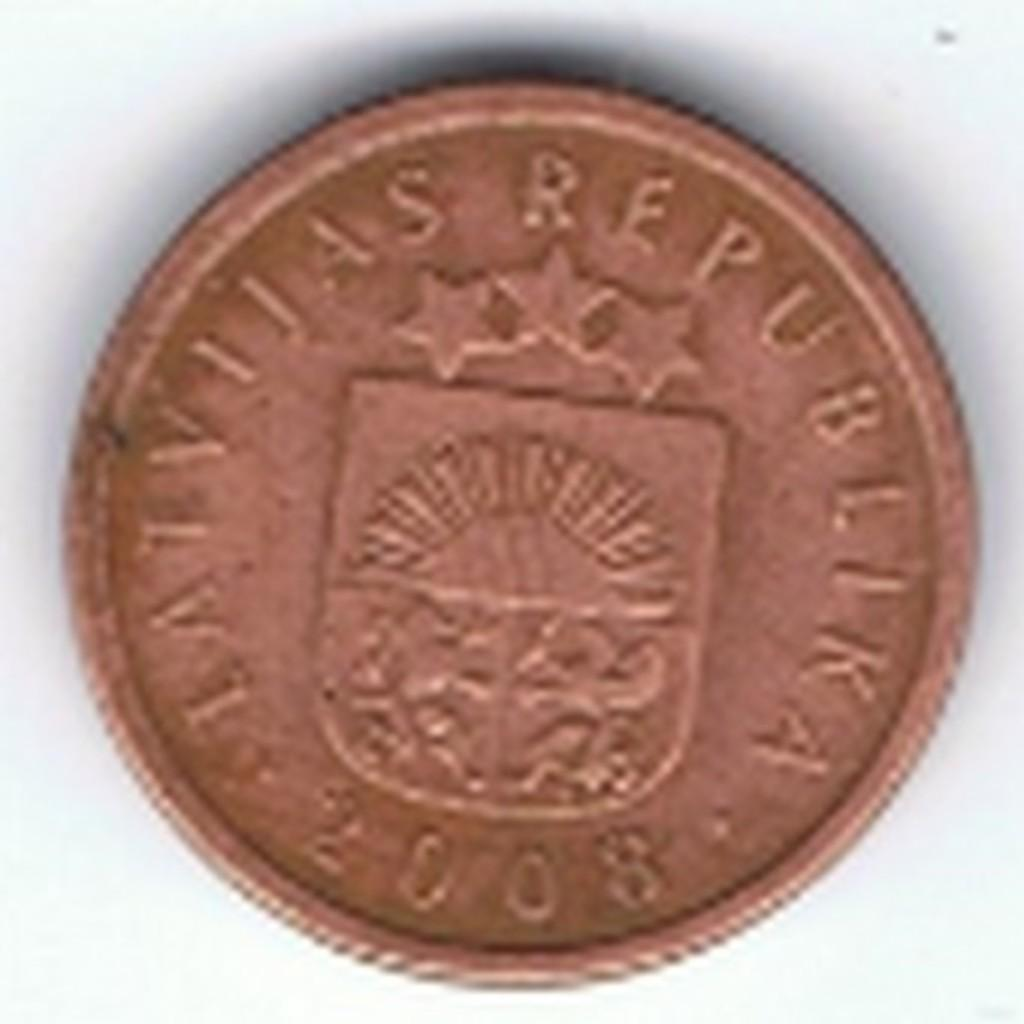What type of coin is featured in the image? There is a bronze coin in the image. How many geese are depicted on the bronze coin in the image? There are no geese depicted on the bronze coin in the image. What mark is visible on the reverse side of the bronze coin in the image? The provided fact does not mention any marks or details about the reverse side of the coin, so we cannot answer this question. 